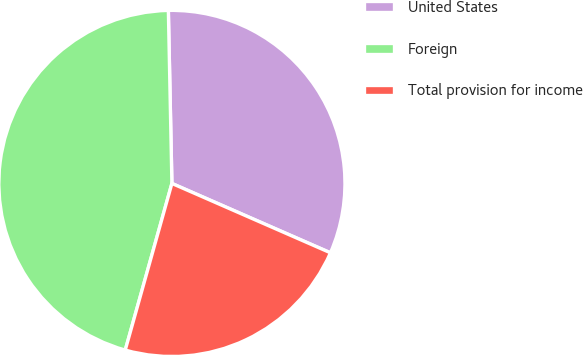Convert chart to OTSL. <chart><loc_0><loc_0><loc_500><loc_500><pie_chart><fcel>United States<fcel>Foreign<fcel>Total provision for income<nl><fcel>31.89%<fcel>45.33%<fcel>22.78%<nl></chart> 